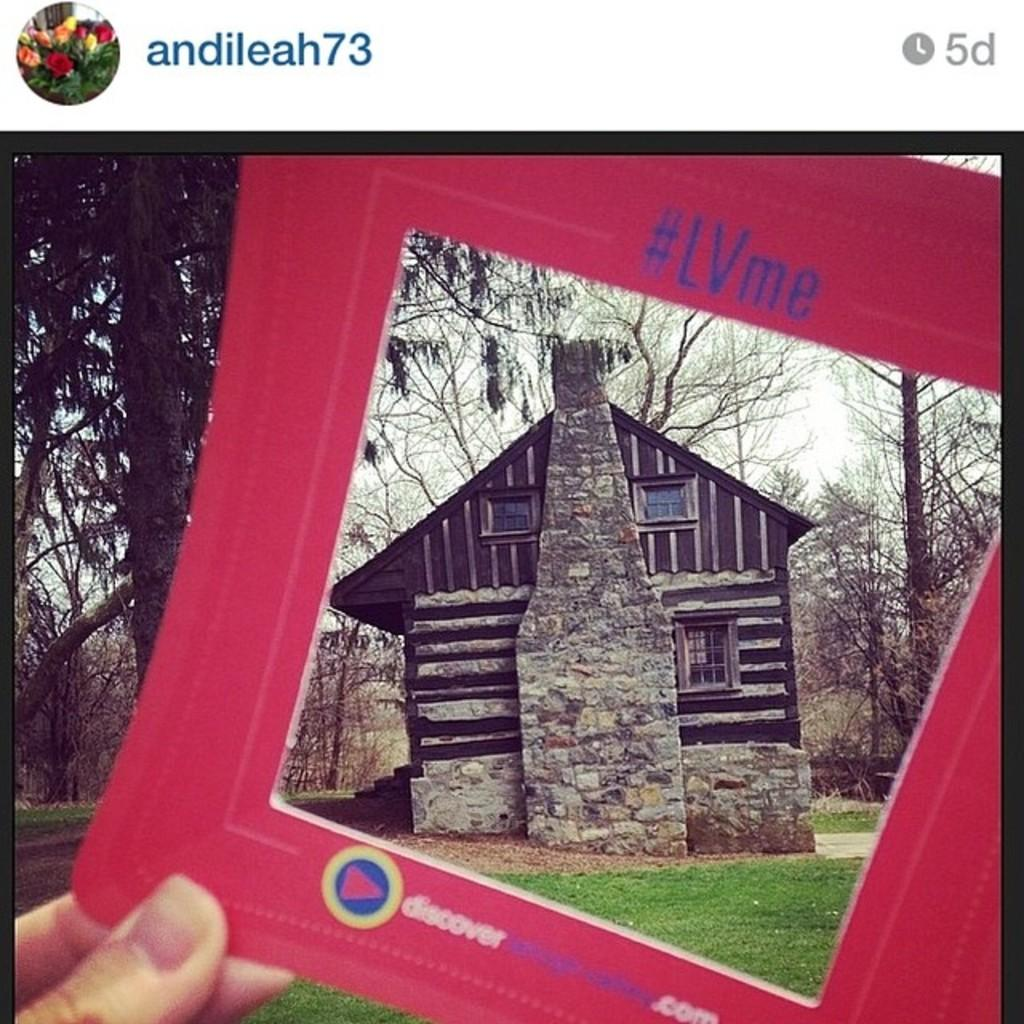What is the main subject of the image? The main subject of the image is a poster of a social website. What is the person's hand holding in the image? The person's hand is holding a pink cardboard in the image. What can be seen in the background of the image? There are trees, grass, and the sky visible in the background of the image. What type of destruction can be seen in the image? There is no destruction present in the image; it features a poster of a social website with a person's hand holding a pink cardboard and a background of trees, grass, and the sky. What type of locket is hanging from the trees in the image? There is no locket present in the image; it only features a poster of a social website, a person's hand holding a pink cardboard, and a background of trees, grass, and the sky. 